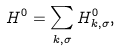<formula> <loc_0><loc_0><loc_500><loc_500>H ^ { 0 } = \sum _ { { k } , \sigma } H ^ { 0 } _ { { k } , \sigma } ,</formula> 